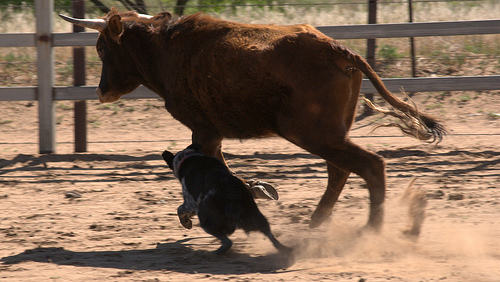<image>
Can you confirm if the dog is behind the bull? No. The dog is not behind the bull. From this viewpoint, the dog appears to be positioned elsewhere in the scene. Is there a dog to the right of the cow? No. The dog is not to the right of the cow. The horizontal positioning shows a different relationship. 